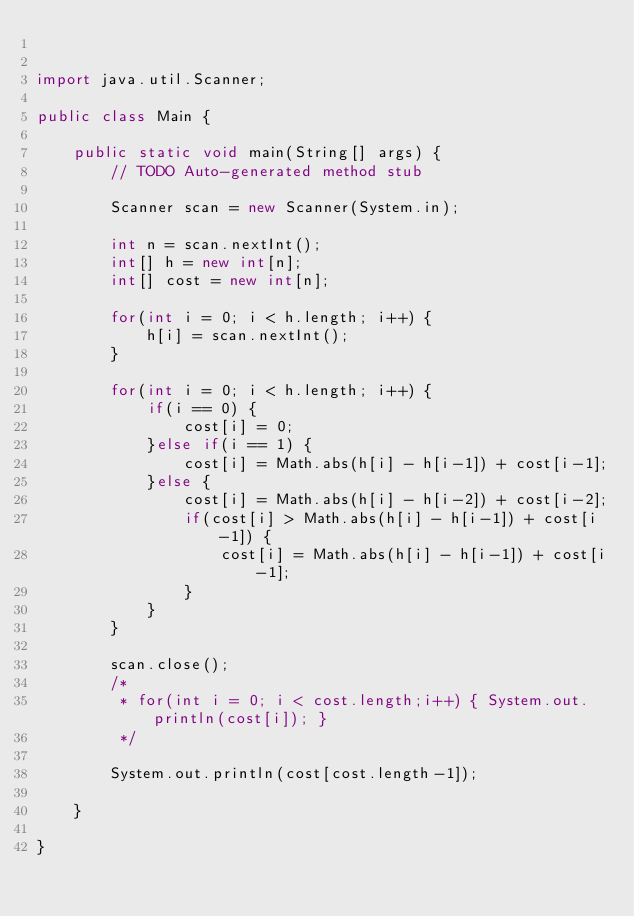Convert code to text. <code><loc_0><loc_0><loc_500><loc_500><_Java_>

import java.util.Scanner;

public class Main {

	public static void main(String[] args) {
		// TODO Auto-generated method stub

		Scanner scan = new Scanner(System.in);
		
		int n = scan.nextInt();
		int[] h = new int[n];
		int[] cost = new int[n];
		
		for(int i = 0; i < h.length; i++) {
			h[i] = scan.nextInt();
		}
		
		for(int i = 0; i < h.length; i++) {
			if(i == 0) {
				cost[i] = 0;
			}else if(i == 1) {
				cost[i] = Math.abs(h[i] - h[i-1]) + cost[i-1];
			}else {
				cost[i] = Math.abs(h[i] - h[i-2]) + cost[i-2];
				if(cost[i] > Math.abs(h[i] - h[i-1]) + cost[i-1]) {
					cost[i] = Math.abs(h[i] - h[i-1]) + cost[i-1];
				}
			}
		}
		
		scan.close();
		/*
		 * for(int i = 0; i < cost.length;i++) { System.out.println(cost[i]); }
		 */
		
		System.out.println(cost[cost.length-1]);
		
	}

}
</code> 